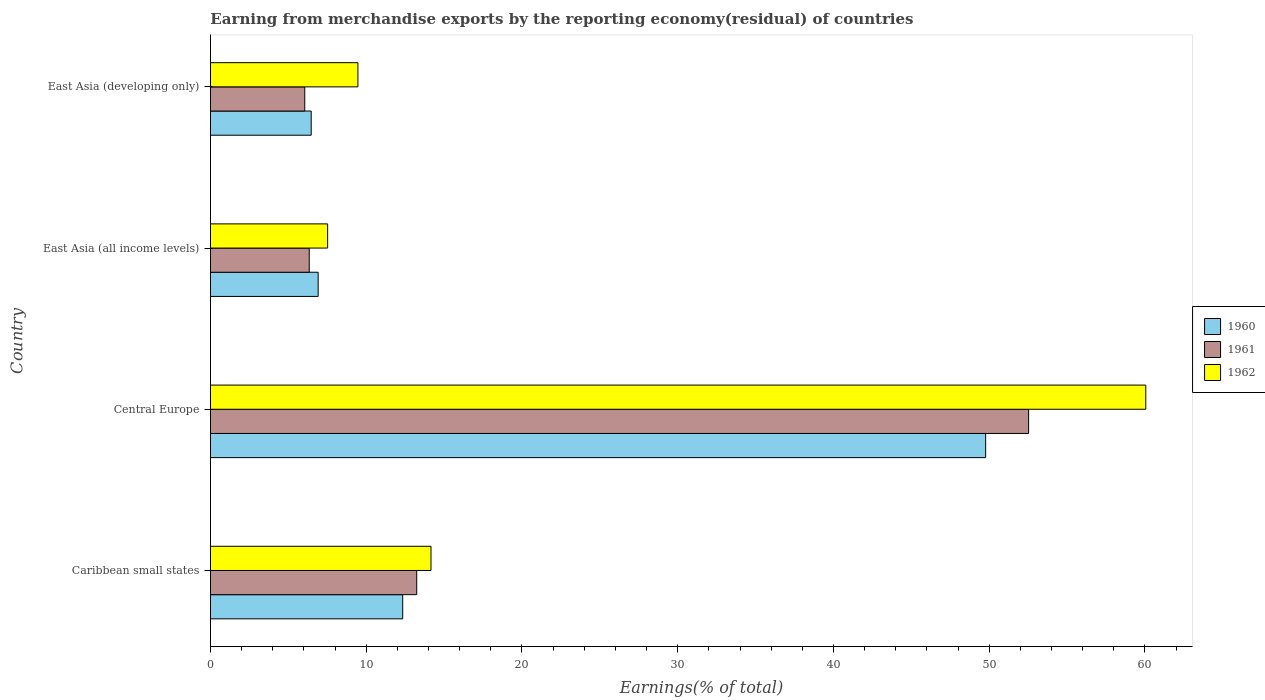How many different coloured bars are there?
Your response must be concise. 3. How many groups of bars are there?
Offer a terse response. 4. Are the number of bars on each tick of the Y-axis equal?
Your response must be concise. Yes. What is the label of the 2nd group of bars from the top?
Offer a terse response. East Asia (all income levels). What is the percentage of amount earned from merchandise exports in 1961 in East Asia (all income levels)?
Offer a very short reply. 6.34. Across all countries, what is the maximum percentage of amount earned from merchandise exports in 1961?
Make the answer very short. 52.53. Across all countries, what is the minimum percentage of amount earned from merchandise exports in 1960?
Give a very brief answer. 6.47. In which country was the percentage of amount earned from merchandise exports in 1962 maximum?
Offer a very short reply. Central Europe. In which country was the percentage of amount earned from merchandise exports in 1961 minimum?
Keep it short and to the point. East Asia (developing only). What is the total percentage of amount earned from merchandise exports in 1961 in the graph?
Offer a very short reply. 78.17. What is the difference between the percentage of amount earned from merchandise exports in 1962 in Caribbean small states and that in East Asia (developing only)?
Offer a very short reply. 4.69. What is the difference between the percentage of amount earned from merchandise exports in 1961 in Caribbean small states and the percentage of amount earned from merchandise exports in 1962 in Central Europe?
Your response must be concise. -46.81. What is the average percentage of amount earned from merchandise exports in 1960 per country?
Your answer should be compact. 18.87. What is the difference between the percentage of amount earned from merchandise exports in 1961 and percentage of amount earned from merchandise exports in 1962 in Caribbean small states?
Your response must be concise. -0.92. In how many countries, is the percentage of amount earned from merchandise exports in 1962 greater than 50 %?
Keep it short and to the point. 1. What is the ratio of the percentage of amount earned from merchandise exports in 1962 in Central Europe to that in East Asia (all income levels)?
Offer a terse response. 7.98. Is the difference between the percentage of amount earned from merchandise exports in 1961 in Central Europe and East Asia (developing only) greater than the difference between the percentage of amount earned from merchandise exports in 1962 in Central Europe and East Asia (developing only)?
Make the answer very short. No. What is the difference between the highest and the second highest percentage of amount earned from merchandise exports in 1960?
Offer a very short reply. 37.43. What is the difference between the highest and the lowest percentage of amount earned from merchandise exports in 1962?
Ensure brevity in your answer.  52.53. In how many countries, is the percentage of amount earned from merchandise exports in 1960 greater than the average percentage of amount earned from merchandise exports in 1960 taken over all countries?
Provide a succinct answer. 1. Is the sum of the percentage of amount earned from merchandise exports in 1961 in Caribbean small states and East Asia (all income levels) greater than the maximum percentage of amount earned from merchandise exports in 1962 across all countries?
Offer a very short reply. No. What does the 1st bar from the top in East Asia (developing only) represents?
Make the answer very short. 1962. What does the 2nd bar from the bottom in Central Europe represents?
Provide a short and direct response. 1961. Is it the case that in every country, the sum of the percentage of amount earned from merchandise exports in 1962 and percentage of amount earned from merchandise exports in 1960 is greater than the percentage of amount earned from merchandise exports in 1961?
Keep it short and to the point. Yes. Does the graph contain grids?
Offer a very short reply. No. How many legend labels are there?
Ensure brevity in your answer.  3. How are the legend labels stacked?
Ensure brevity in your answer.  Vertical. What is the title of the graph?
Make the answer very short. Earning from merchandise exports by the reporting economy(residual) of countries. What is the label or title of the X-axis?
Make the answer very short. Earnings(% of total). What is the Earnings(% of total) of 1960 in Caribbean small states?
Provide a succinct answer. 12.34. What is the Earnings(% of total) in 1961 in Caribbean small states?
Your answer should be compact. 13.24. What is the Earnings(% of total) in 1962 in Caribbean small states?
Provide a succinct answer. 14.16. What is the Earnings(% of total) in 1960 in Central Europe?
Give a very brief answer. 49.77. What is the Earnings(% of total) in 1961 in Central Europe?
Your answer should be compact. 52.53. What is the Earnings(% of total) of 1962 in Central Europe?
Provide a short and direct response. 60.05. What is the Earnings(% of total) in 1960 in East Asia (all income levels)?
Offer a terse response. 6.91. What is the Earnings(% of total) of 1961 in East Asia (all income levels)?
Your answer should be very brief. 6.34. What is the Earnings(% of total) in 1962 in East Asia (all income levels)?
Offer a terse response. 7.52. What is the Earnings(% of total) of 1960 in East Asia (developing only)?
Make the answer very short. 6.47. What is the Earnings(% of total) in 1961 in East Asia (developing only)?
Your answer should be compact. 6.05. What is the Earnings(% of total) in 1962 in East Asia (developing only)?
Provide a short and direct response. 9.47. Across all countries, what is the maximum Earnings(% of total) in 1960?
Ensure brevity in your answer.  49.77. Across all countries, what is the maximum Earnings(% of total) of 1961?
Your response must be concise. 52.53. Across all countries, what is the maximum Earnings(% of total) in 1962?
Provide a succinct answer. 60.05. Across all countries, what is the minimum Earnings(% of total) of 1960?
Give a very brief answer. 6.47. Across all countries, what is the minimum Earnings(% of total) in 1961?
Ensure brevity in your answer.  6.05. Across all countries, what is the minimum Earnings(% of total) of 1962?
Give a very brief answer. 7.52. What is the total Earnings(% of total) of 1960 in the graph?
Your response must be concise. 75.5. What is the total Earnings(% of total) in 1961 in the graph?
Keep it short and to the point. 78.17. What is the total Earnings(% of total) of 1962 in the graph?
Make the answer very short. 91.2. What is the difference between the Earnings(% of total) of 1960 in Caribbean small states and that in Central Europe?
Make the answer very short. -37.43. What is the difference between the Earnings(% of total) of 1961 in Caribbean small states and that in Central Europe?
Give a very brief answer. -39.29. What is the difference between the Earnings(% of total) of 1962 in Caribbean small states and that in Central Europe?
Provide a succinct answer. -45.9. What is the difference between the Earnings(% of total) of 1960 in Caribbean small states and that in East Asia (all income levels)?
Ensure brevity in your answer.  5.43. What is the difference between the Earnings(% of total) in 1961 in Caribbean small states and that in East Asia (all income levels)?
Offer a very short reply. 6.9. What is the difference between the Earnings(% of total) of 1962 in Caribbean small states and that in East Asia (all income levels)?
Make the answer very short. 6.64. What is the difference between the Earnings(% of total) of 1960 in Caribbean small states and that in East Asia (developing only)?
Keep it short and to the point. 5.88. What is the difference between the Earnings(% of total) of 1961 in Caribbean small states and that in East Asia (developing only)?
Offer a terse response. 7.19. What is the difference between the Earnings(% of total) of 1962 in Caribbean small states and that in East Asia (developing only)?
Offer a terse response. 4.69. What is the difference between the Earnings(% of total) of 1960 in Central Europe and that in East Asia (all income levels)?
Offer a terse response. 42.86. What is the difference between the Earnings(% of total) of 1961 in Central Europe and that in East Asia (all income levels)?
Keep it short and to the point. 46.19. What is the difference between the Earnings(% of total) of 1962 in Central Europe and that in East Asia (all income levels)?
Your answer should be compact. 52.53. What is the difference between the Earnings(% of total) in 1960 in Central Europe and that in East Asia (developing only)?
Give a very brief answer. 43.3. What is the difference between the Earnings(% of total) of 1961 in Central Europe and that in East Asia (developing only)?
Make the answer very short. 46.48. What is the difference between the Earnings(% of total) of 1962 in Central Europe and that in East Asia (developing only)?
Your answer should be compact. 50.59. What is the difference between the Earnings(% of total) of 1960 in East Asia (all income levels) and that in East Asia (developing only)?
Give a very brief answer. 0.45. What is the difference between the Earnings(% of total) of 1961 in East Asia (all income levels) and that in East Asia (developing only)?
Your answer should be very brief. 0.29. What is the difference between the Earnings(% of total) of 1962 in East Asia (all income levels) and that in East Asia (developing only)?
Keep it short and to the point. -1.94. What is the difference between the Earnings(% of total) of 1960 in Caribbean small states and the Earnings(% of total) of 1961 in Central Europe?
Ensure brevity in your answer.  -40.19. What is the difference between the Earnings(% of total) of 1960 in Caribbean small states and the Earnings(% of total) of 1962 in Central Europe?
Give a very brief answer. -47.71. What is the difference between the Earnings(% of total) of 1961 in Caribbean small states and the Earnings(% of total) of 1962 in Central Europe?
Offer a terse response. -46.81. What is the difference between the Earnings(% of total) of 1960 in Caribbean small states and the Earnings(% of total) of 1961 in East Asia (all income levels)?
Offer a very short reply. 6. What is the difference between the Earnings(% of total) in 1960 in Caribbean small states and the Earnings(% of total) in 1962 in East Asia (all income levels)?
Keep it short and to the point. 4.82. What is the difference between the Earnings(% of total) of 1961 in Caribbean small states and the Earnings(% of total) of 1962 in East Asia (all income levels)?
Ensure brevity in your answer.  5.72. What is the difference between the Earnings(% of total) in 1960 in Caribbean small states and the Earnings(% of total) in 1961 in East Asia (developing only)?
Your answer should be very brief. 6.29. What is the difference between the Earnings(% of total) in 1960 in Caribbean small states and the Earnings(% of total) in 1962 in East Asia (developing only)?
Provide a short and direct response. 2.88. What is the difference between the Earnings(% of total) in 1961 in Caribbean small states and the Earnings(% of total) in 1962 in East Asia (developing only)?
Make the answer very short. 3.78. What is the difference between the Earnings(% of total) in 1960 in Central Europe and the Earnings(% of total) in 1961 in East Asia (all income levels)?
Your response must be concise. 43.43. What is the difference between the Earnings(% of total) in 1960 in Central Europe and the Earnings(% of total) in 1962 in East Asia (all income levels)?
Make the answer very short. 42.25. What is the difference between the Earnings(% of total) in 1961 in Central Europe and the Earnings(% of total) in 1962 in East Asia (all income levels)?
Make the answer very short. 45.01. What is the difference between the Earnings(% of total) in 1960 in Central Europe and the Earnings(% of total) in 1961 in East Asia (developing only)?
Give a very brief answer. 43.72. What is the difference between the Earnings(% of total) of 1960 in Central Europe and the Earnings(% of total) of 1962 in East Asia (developing only)?
Offer a very short reply. 40.3. What is the difference between the Earnings(% of total) of 1961 in Central Europe and the Earnings(% of total) of 1962 in East Asia (developing only)?
Keep it short and to the point. 43.06. What is the difference between the Earnings(% of total) in 1960 in East Asia (all income levels) and the Earnings(% of total) in 1961 in East Asia (developing only)?
Ensure brevity in your answer.  0.86. What is the difference between the Earnings(% of total) in 1960 in East Asia (all income levels) and the Earnings(% of total) in 1962 in East Asia (developing only)?
Your response must be concise. -2.55. What is the difference between the Earnings(% of total) in 1961 in East Asia (all income levels) and the Earnings(% of total) in 1962 in East Asia (developing only)?
Offer a very short reply. -3.12. What is the average Earnings(% of total) of 1960 per country?
Give a very brief answer. 18.87. What is the average Earnings(% of total) in 1961 per country?
Keep it short and to the point. 19.54. What is the average Earnings(% of total) of 1962 per country?
Provide a short and direct response. 22.8. What is the difference between the Earnings(% of total) of 1960 and Earnings(% of total) of 1961 in Caribbean small states?
Offer a terse response. -0.9. What is the difference between the Earnings(% of total) in 1960 and Earnings(% of total) in 1962 in Caribbean small states?
Make the answer very short. -1.82. What is the difference between the Earnings(% of total) in 1961 and Earnings(% of total) in 1962 in Caribbean small states?
Offer a very short reply. -0.92. What is the difference between the Earnings(% of total) of 1960 and Earnings(% of total) of 1961 in Central Europe?
Offer a terse response. -2.76. What is the difference between the Earnings(% of total) in 1960 and Earnings(% of total) in 1962 in Central Europe?
Make the answer very short. -10.28. What is the difference between the Earnings(% of total) of 1961 and Earnings(% of total) of 1962 in Central Europe?
Ensure brevity in your answer.  -7.52. What is the difference between the Earnings(% of total) of 1960 and Earnings(% of total) of 1961 in East Asia (all income levels)?
Give a very brief answer. 0.57. What is the difference between the Earnings(% of total) in 1960 and Earnings(% of total) in 1962 in East Asia (all income levels)?
Offer a terse response. -0.61. What is the difference between the Earnings(% of total) in 1961 and Earnings(% of total) in 1962 in East Asia (all income levels)?
Ensure brevity in your answer.  -1.18. What is the difference between the Earnings(% of total) of 1960 and Earnings(% of total) of 1961 in East Asia (developing only)?
Your answer should be very brief. 0.41. What is the difference between the Earnings(% of total) of 1960 and Earnings(% of total) of 1962 in East Asia (developing only)?
Keep it short and to the point. -3. What is the difference between the Earnings(% of total) of 1961 and Earnings(% of total) of 1962 in East Asia (developing only)?
Make the answer very short. -3.41. What is the ratio of the Earnings(% of total) in 1960 in Caribbean small states to that in Central Europe?
Provide a succinct answer. 0.25. What is the ratio of the Earnings(% of total) in 1961 in Caribbean small states to that in Central Europe?
Offer a very short reply. 0.25. What is the ratio of the Earnings(% of total) in 1962 in Caribbean small states to that in Central Europe?
Give a very brief answer. 0.24. What is the ratio of the Earnings(% of total) in 1960 in Caribbean small states to that in East Asia (all income levels)?
Provide a short and direct response. 1.79. What is the ratio of the Earnings(% of total) in 1961 in Caribbean small states to that in East Asia (all income levels)?
Give a very brief answer. 2.09. What is the ratio of the Earnings(% of total) of 1962 in Caribbean small states to that in East Asia (all income levels)?
Keep it short and to the point. 1.88. What is the ratio of the Earnings(% of total) of 1960 in Caribbean small states to that in East Asia (developing only)?
Give a very brief answer. 1.91. What is the ratio of the Earnings(% of total) of 1961 in Caribbean small states to that in East Asia (developing only)?
Ensure brevity in your answer.  2.19. What is the ratio of the Earnings(% of total) of 1962 in Caribbean small states to that in East Asia (developing only)?
Make the answer very short. 1.5. What is the ratio of the Earnings(% of total) of 1960 in Central Europe to that in East Asia (all income levels)?
Keep it short and to the point. 7.2. What is the ratio of the Earnings(% of total) of 1961 in Central Europe to that in East Asia (all income levels)?
Ensure brevity in your answer.  8.28. What is the ratio of the Earnings(% of total) in 1962 in Central Europe to that in East Asia (all income levels)?
Your answer should be compact. 7.98. What is the ratio of the Earnings(% of total) of 1960 in Central Europe to that in East Asia (developing only)?
Your answer should be compact. 7.7. What is the ratio of the Earnings(% of total) in 1961 in Central Europe to that in East Asia (developing only)?
Your response must be concise. 8.68. What is the ratio of the Earnings(% of total) of 1962 in Central Europe to that in East Asia (developing only)?
Your response must be concise. 6.34. What is the ratio of the Earnings(% of total) in 1960 in East Asia (all income levels) to that in East Asia (developing only)?
Give a very brief answer. 1.07. What is the ratio of the Earnings(% of total) of 1961 in East Asia (all income levels) to that in East Asia (developing only)?
Ensure brevity in your answer.  1.05. What is the ratio of the Earnings(% of total) in 1962 in East Asia (all income levels) to that in East Asia (developing only)?
Your answer should be very brief. 0.79. What is the difference between the highest and the second highest Earnings(% of total) in 1960?
Give a very brief answer. 37.43. What is the difference between the highest and the second highest Earnings(% of total) of 1961?
Your answer should be very brief. 39.29. What is the difference between the highest and the second highest Earnings(% of total) in 1962?
Provide a succinct answer. 45.9. What is the difference between the highest and the lowest Earnings(% of total) of 1960?
Provide a short and direct response. 43.3. What is the difference between the highest and the lowest Earnings(% of total) of 1961?
Offer a terse response. 46.48. What is the difference between the highest and the lowest Earnings(% of total) in 1962?
Your answer should be very brief. 52.53. 